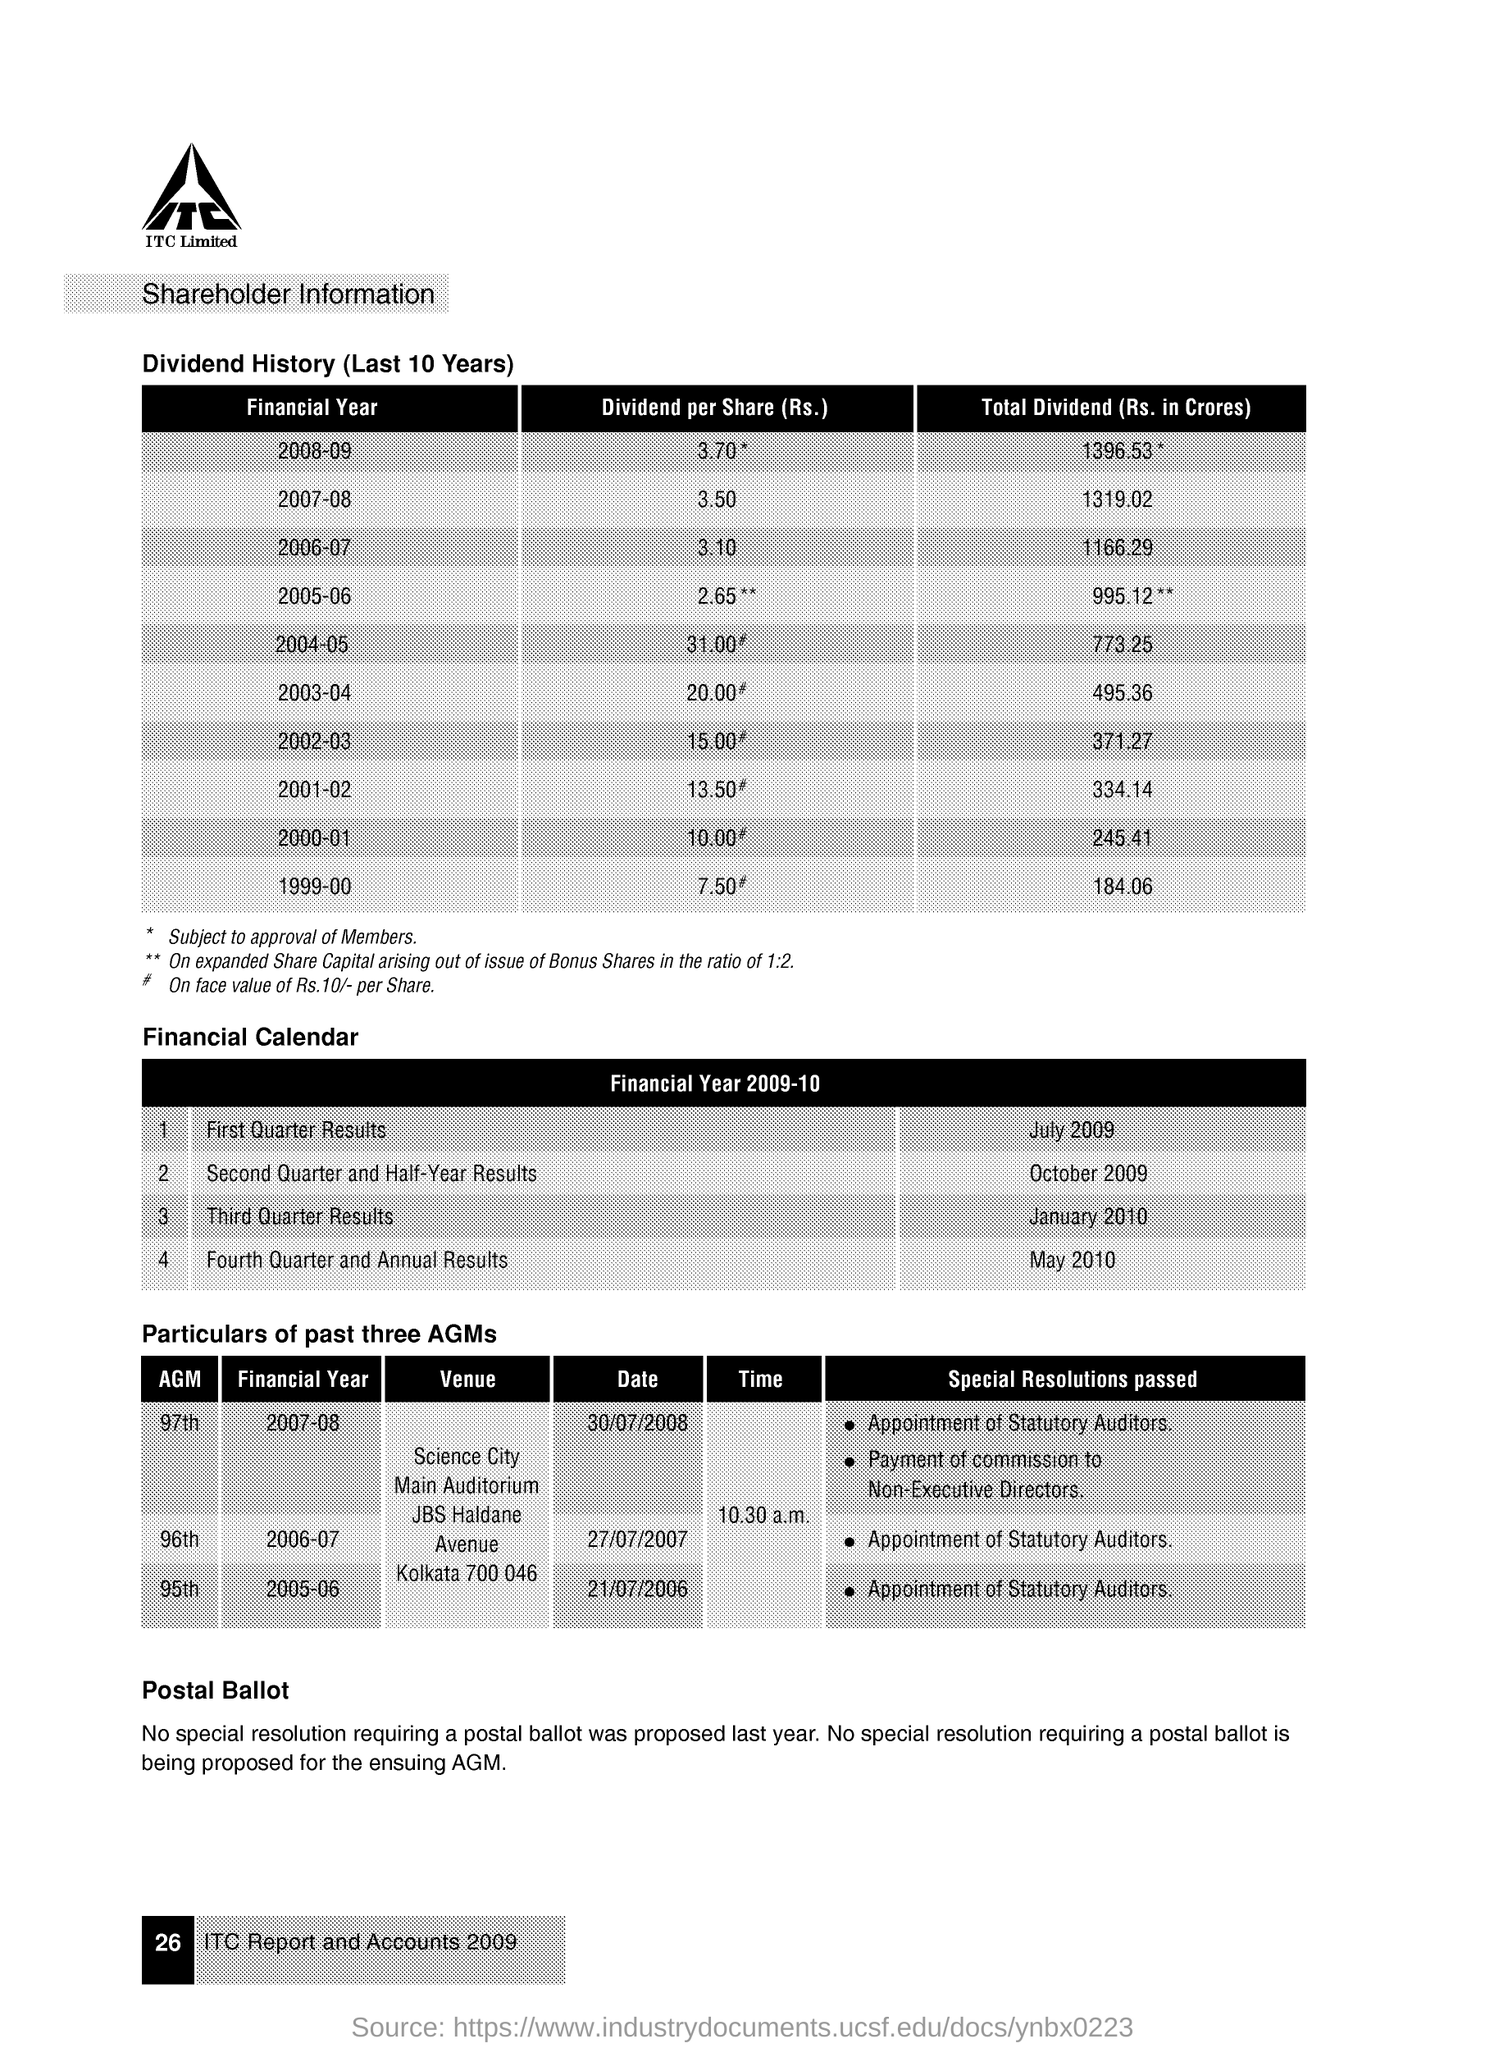Give some essential details in this illustration. During the financial year 2005-06, one of the special resolutions that was passed in the 95th Annual General Meeting (AGM) was the appointment of statutory auditors. The 97th Annual General Meeting (AGM) was conducted in the financial year 2007-2008. The dividend per share for the financial year 2007-08 was Rs. 3.50. The third quarter results were announced in the financial year 2009-10 in January 2010. The first quarter results were announced in the financial year 2009-10 in July 2009. 